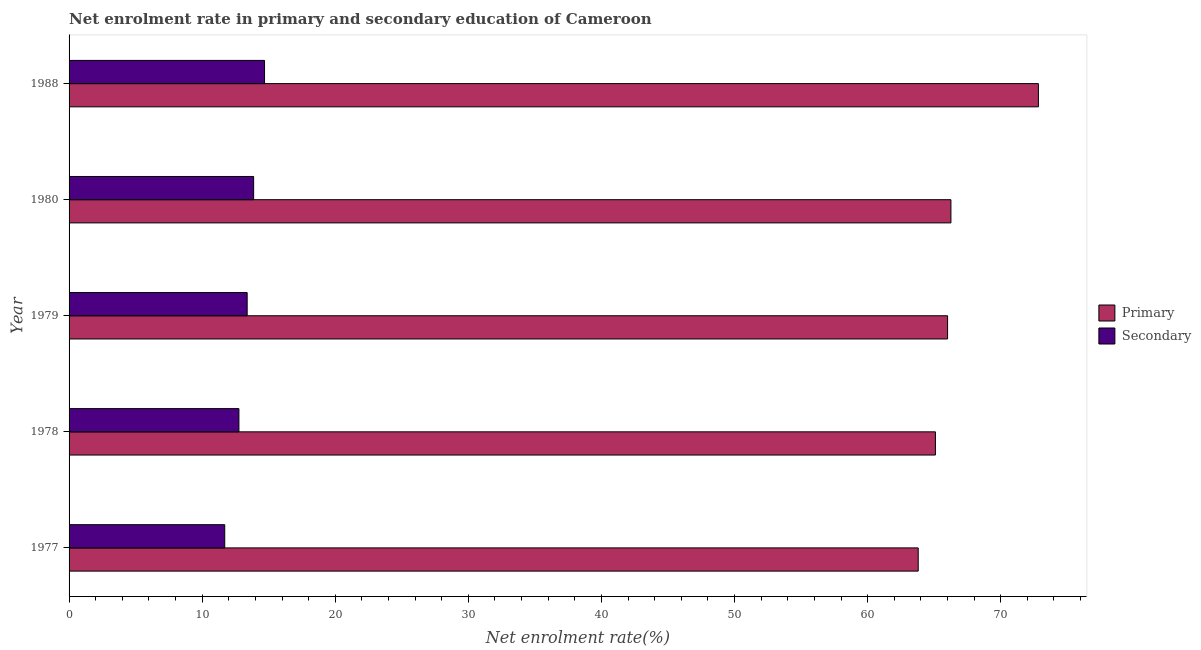How many different coloured bars are there?
Keep it short and to the point. 2. Are the number of bars on each tick of the Y-axis equal?
Your answer should be very brief. Yes. How many bars are there on the 4th tick from the bottom?
Provide a short and direct response. 2. What is the enrollment rate in primary education in 1978?
Give a very brief answer. 65.09. Across all years, what is the maximum enrollment rate in secondary education?
Provide a short and direct response. 14.69. Across all years, what is the minimum enrollment rate in primary education?
Your answer should be very brief. 63.8. In which year was the enrollment rate in primary education maximum?
Your answer should be compact. 1988. What is the total enrollment rate in secondary education in the graph?
Your response must be concise. 66.39. What is the difference between the enrollment rate in primary education in 1979 and that in 1988?
Make the answer very short. -6.82. What is the difference between the enrollment rate in primary education in 1978 and the enrollment rate in secondary education in 1977?
Ensure brevity in your answer.  53.4. What is the average enrollment rate in secondary education per year?
Your response must be concise. 13.28. In the year 1988, what is the difference between the enrollment rate in secondary education and enrollment rate in primary education?
Your answer should be compact. -58.14. In how many years, is the enrollment rate in primary education greater than 74 %?
Offer a very short reply. 0. What is the ratio of the enrollment rate in secondary education in 1977 to that in 1980?
Provide a short and direct response. 0.84. Is the enrollment rate in secondary education in 1978 less than that in 1979?
Provide a short and direct response. Yes. Is the difference between the enrollment rate in secondary education in 1978 and 1980 greater than the difference between the enrollment rate in primary education in 1978 and 1980?
Your answer should be compact. Yes. What is the difference between the highest and the second highest enrollment rate in primary education?
Keep it short and to the point. 6.57. What is the difference between the highest and the lowest enrollment rate in secondary education?
Offer a very short reply. 2.99. In how many years, is the enrollment rate in primary education greater than the average enrollment rate in primary education taken over all years?
Your response must be concise. 1. Is the sum of the enrollment rate in primary education in 1978 and 1979 greater than the maximum enrollment rate in secondary education across all years?
Offer a terse response. Yes. What does the 2nd bar from the top in 1979 represents?
Provide a short and direct response. Primary. What does the 1st bar from the bottom in 1979 represents?
Offer a terse response. Primary. How many bars are there?
Provide a succinct answer. 10. Are all the bars in the graph horizontal?
Give a very brief answer. Yes. What is the difference between two consecutive major ticks on the X-axis?
Offer a very short reply. 10. Where does the legend appear in the graph?
Your response must be concise. Center right. How are the legend labels stacked?
Provide a short and direct response. Vertical. What is the title of the graph?
Offer a terse response. Net enrolment rate in primary and secondary education of Cameroon. What is the label or title of the X-axis?
Provide a short and direct response. Net enrolment rate(%). What is the label or title of the Y-axis?
Ensure brevity in your answer.  Year. What is the Net enrolment rate(%) of Primary in 1977?
Your answer should be very brief. 63.8. What is the Net enrolment rate(%) in Secondary in 1977?
Offer a very short reply. 11.7. What is the Net enrolment rate(%) of Primary in 1978?
Provide a short and direct response. 65.09. What is the Net enrolment rate(%) of Secondary in 1978?
Give a very brief answer. 12.76. What is the Net enrolment rate(%) of Primary in 1979?
Ensure brevity in your answer.  66.01. What is the Net enrolment rate(%) in Secondary in 1979?
Your answer should be very brief. 13.38. What is the Net enrolment rate(%) in Primary in 1980?
Offer a very short reply. 66.26. What is the Net enrolment rate(%) of Secondary in 1980?
Give a very brief answer. 13.87. What is the Net enrolment rate(%) of Primary in 1988?
Your response must be concise. 72.83. What is the Net enrolment rate(%) in Secondary in 1988?
Offer a very short reply. 14.69. Across all years, what is the maximum Net enrolment rate(%) of Primary?
Give a very brief answer. 72.83. Across all years, what is the maximum Net enrolment rate(%) in Secondary?
Ensure brevity in your answer.  14.69. Across all years, what is the minimum Net enrolment rate(%) in Primary?
Provide a short and direct response. 63.8. Across all years, what is the minimum Net enrolment rate(%) in Secondary?
Keep it short and to the point. 11.7. What is the total Net enrolment rate(%) in Primary in the graph?
Make the answer very short. 333.99. What is the total Net enrolment rate(%) in Secondary in the graph?
Your response must be concise. 66.39. What is the difference between the Net enrolment rate(%) in Primary in 1977 and that in 1978?
Your response must be concise. -1.29. What is the difference between the Net enrolment rate(%) of Secondary in 1977 and that in 1978?
Keep it short and to the point. -1.07. What is the difference between the Net enrolment rate(%) of Primary in 1977 and that in 1979?
Make the answer very short. -2.21. What is the difference between the Net enrolment rate(%) in Secondary in 1977 and that in 1979?
Offer a very short reply. -1.68. What is the difference between the Net enrolment rate(%) in Primary in 1977 and that in 1980?
Your response must be concise. -2.46. What is the difference between the Net enrolment rate(%) of Secondary in 1977 and that in 1980?
Your response must be concise. -2.17. What is the difference between the Net enrolment rate(%) of Primary in 1977 and that in 1988?
Ensure brevity in your answer.  -9.03. What is the difference between the Net enrolment rate(%) of Secondary in 1977 and that in 1988?
Keep it short and to the point. -2.99. What is the difference between the Net enrolment rate(%) of Primary in 1978 and that in 1979?
Offer a terse response. -0.91. What is the difference between the Net enrolment rate(%) of Secondary in 1978 and that in 1979?
Provide a short and direct response. -0.62. What is the difference between the Net enrolment rate(%) in Primary in 1978 and that in 1980?
Your answer should be very brief. -1.16. What is the difference between the Net enrolment rate(%) in Secondary in 1978 and that in 1980?
Keep it short and to the point. -1.11. What is the difference between the Net enrolment rate(%) of Primary in 1978 and that in 1988?
Make the answer very short. -7.74. What is the difference between the Net enrolment rate(%) in Secondary in 1978 and that in 1988?
Provide a short and direct response. -1.92. What is the difference between the Net enrolment rate(%) in Primary in 1979 and that in 1980?
Your answer should be compact. -0.25. What is the difference between the Net enrolment rate(%) in Secondary in 1979 and that in 1980?
Offer a terse response. -0.49. What is the difference between the Net enrolment rate(%) of Primary in 1979 and that in 1988?
Make the answer very short. -6.82. What is the difference between the Net enrolment rate(%) of Secondary in 1979 and that in 1988?
Provide a succinct answer. -1.31. What is the difference between the Net enrolment rate(%) of Primary in 1980 and that in 1988?
Your answer should be very brief. -6.57. What is the difference between the Net enrolment rate(%) of Secondary in 1980 and that in 1988?
Your answer should be compact. -0.82. What is the difference between the Net enrolment rate(%) of Primary in 1977 and the Net enrolment rate(%) of Secondary in 1978?
Ensure brevity in your answer.  51.04. What is the difference between the Net enrolment rate(%) of Primary in 1977 and the Net enrolment rate(%) of Secondary in 1979?
Your response must be concise. 50.42. What is the difference between the Net enrolment rate(%) in Primary in 1977 and the Net enrolment rate(%) in Secondary in 1980?
Make the answer very short. 49.93. What is the difference between the Net enrolment rate(%) in Primary in 1977 and the Net enrolment rate(%) in Secondary in 1988?
Offer a very short reply. 49.11. What is the difference between the Net enrolment rate(%) in Primary in 1978 and the Net enrolment rate(%) in Secondary in 1979?
Your answer should be compact. 51.71. What is the difference between the Net enrolment rate(%) in Primary in 1978 and the Net enrolment rate(%) in Secondary in 1980?
Keep it short and to the point. 51.23. What is the difference between the Net enrolment rate(%) in Primary in 1978 and the Net enrolment rate(%) in Secondary in 1988?
Your response must be concise. 50.41. What is the difference between the Net enrolment rate(%) of Primary in 1979 and the Net enrolment rate(%) of Secondary in 1980?
Your response must be concise. 52.14. What is the difference between the Net enrolment rate(%) in Primary in 1979 and the Net enrolment rate(%) in Secondary in 1988?
Your answer should be compact. 51.32. What is the difference between the Net enrolment rate(%) of Primary in 1980 and the Net enrolment rate(%) of Secondary in 1988?
Keep it short and to the point. 51.57. What is the average Net enrolment rate(%) in Primary per year?
Ensure brevity in your answer.  66.8. What is the average Net enrolment rate(%) in Secondary per year?
Your answer should be compact. 13.28. In the year 1977, what is the difference between the Net enrolment rate(%) of Primary and Net enrolment rate(%) of Secondary?
Keep it short and to the point. 52.1. In the year 1978, what is the difference between the Net enrolment rate(%) of Primary and Net enrolment rate(%) of Secondary?
Keep it short and to the point. 52.33. In the year 1979, what is the difference between the Net enrolment rate(%) of Primary and Net enrolment rate(%) of Secondary?
Your answer should be compact. 52.62. In the year 1980, what is the difference between the Net enrolment rate(%) in Primary and Net enrolment rate(%) in Secondary?
Your answer should be compact. 52.39. In the year 1988, what is the difference between the Net enrolment rate(%) in Primary and Net enrolment rate(%) in Secondary?
Make the answer very short. 58.14. What is the ratio of the Net enrolment rate(%) in Primary in 1977 to that in 1978?
Your answer should be compact. 0.98. What is the ratio of the Net enrolment rate(%) in Secondary in 1977 to that in 1978?
Give a very brief answer. 0.92. What is the ratio of the Net enrolment rate(%) of Primary in 1977 to that in 1979?
Ensure brevity in your answer.  0.97. What is the ratio of the Net enrolment rate(%) in Secondary in 1977 to that in 1979?
Provide a short and direct response. 0.87. What is the ratio of the Net enrolment rate(%) in Primary in 1977 to that in 1980?
Make the answer very short. 0.96. What is the ratio of the Net enrolment rate(%) in Secondary in 1977 to that in 1980?
Keep it short and to the point. 0.84. What is the ratio of the Net enrolment rate(%) in Primary in 1977 to that in 1988?
Make the answer very short. 0.88. What is the ratio of the Net enrolment rate(%) of Secondary in 1977 to that in 1988?
Provide a short and direct response. 0.8. What is the ratio of the Net enrolment rate(%) of Primary in 1978 to that in 1979?
Your answer should be compact. 0.99. What is the ratio of the Net enrolment rate(%) in Secondary in 1978 to that in 1979?
Your answer should be very brief. 0.95. What is the ratio of the Net enrolment rate(%) in Primary in 1978 to that in 1980?
Make the answer very short. 0.98. What is the ratio of the Net enrolment rate(%) of Secondary in 1978 to that in 1980?
Provide a short and direct response. 0.92. What is the ratio of the Net enrolment rate(%) of Primary in 1978 to that in 1988?
Your response must be concise. 0.89. What is the ratio of the Net enrolment rate(%) of Secondary in 1978 to that in 1988?
Offer a terse response. 0.87. What is the ratio of the Net enrolment rate(%) in Secondary in 1979 to that in 1980?
Your answer should be compact. 0.96. What is the ratio of the Net enrolment rate(%) of Primary in 1979 to that in 1988?
Offer a terse response. 0.91. What is the ratio of the Net enrolment rate(%) of Secondary in 1979 to that in 1988?
Ensure brevity in your answer.  0.91. What is the ratio of the Net enrolment rate(%) in Primary in 1980 to that in 1988?
Provide a succinct answer. 0.91. What is the ratio of the Net enrolment rate(%) of Secondary in 1980 to that in 1988?
Provide a succinct answer. 0.94. What is the difference between the highest and the second highest Net enrolment rate(%) in Primary?
Make the answer very short. 6.57. What is the difference between the highest and the second highest Net enrolment rate(%) in Secondary?
Your answer should be compact. 0.82. What is the difference between the highest and the lowest Net enrolment rate(%) of Primary?
Your answer should be very brief. 9.03. What is the difference between the highest and the lowest Net enrolment rate(%) of Secondary?
Provide a short and direct response. 2.99. 